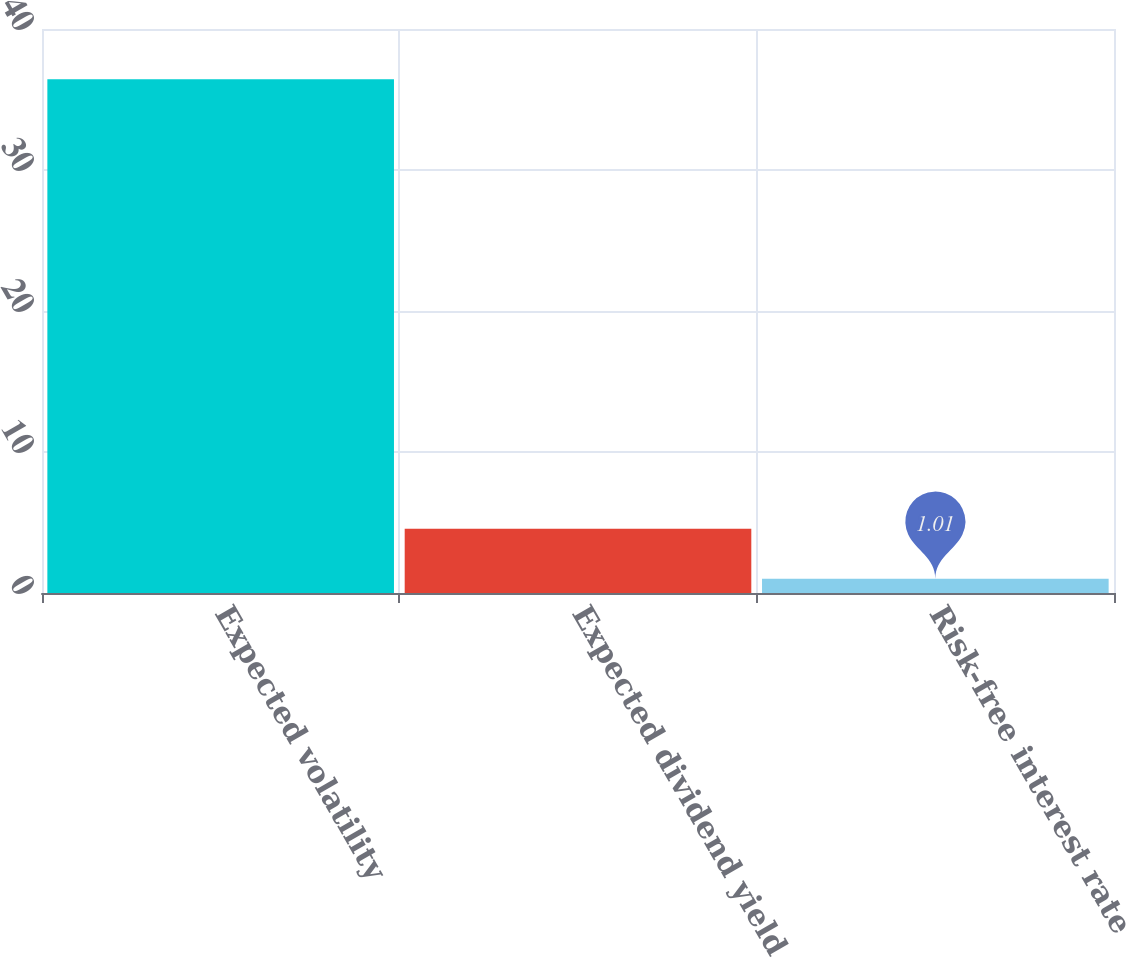Convert chart to OTSL. <chart><loc_0><loc_0><loc_500><loc_500><bar_chart><fcel>Expected volatility<fcel>Expected dividend yield<fcel>Risk-free interest rate<nl><fcel>36.44<fcel>4.55<fcel>1.01<nl></chart> 